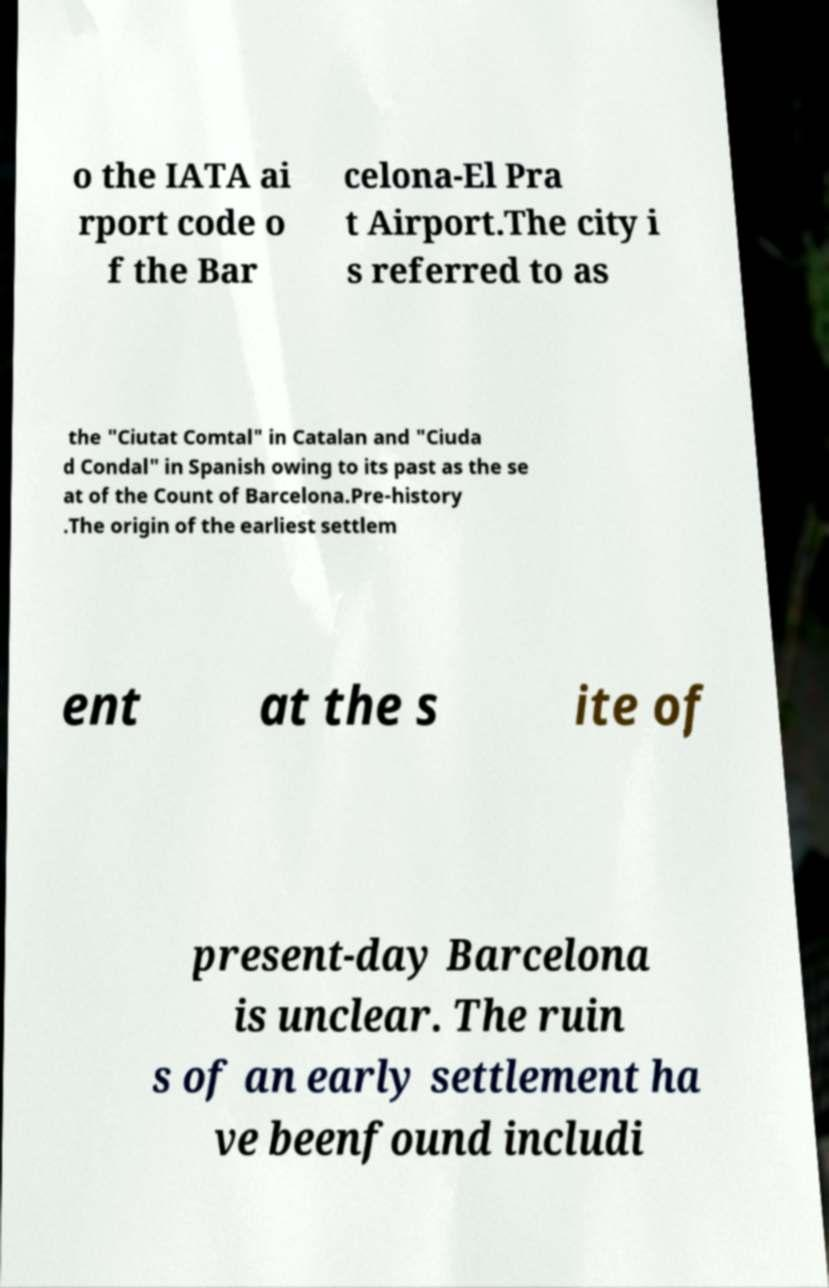Please identify and transcribe the text found in this image. o the IATA ai rport code o f the Bar celona-El Pra t Airport.The city i s referred to as the "Ciutat Comtal" in Catalan and "Ciuda d Condal" in Spanish owing to its past as the se at of the Count of Barcelona.Pre-history .The origin of the earliest settlem ent at the s ite of present-day Barcelona is unclear. The ruin s of an early settlement ha ve beenfound includi 